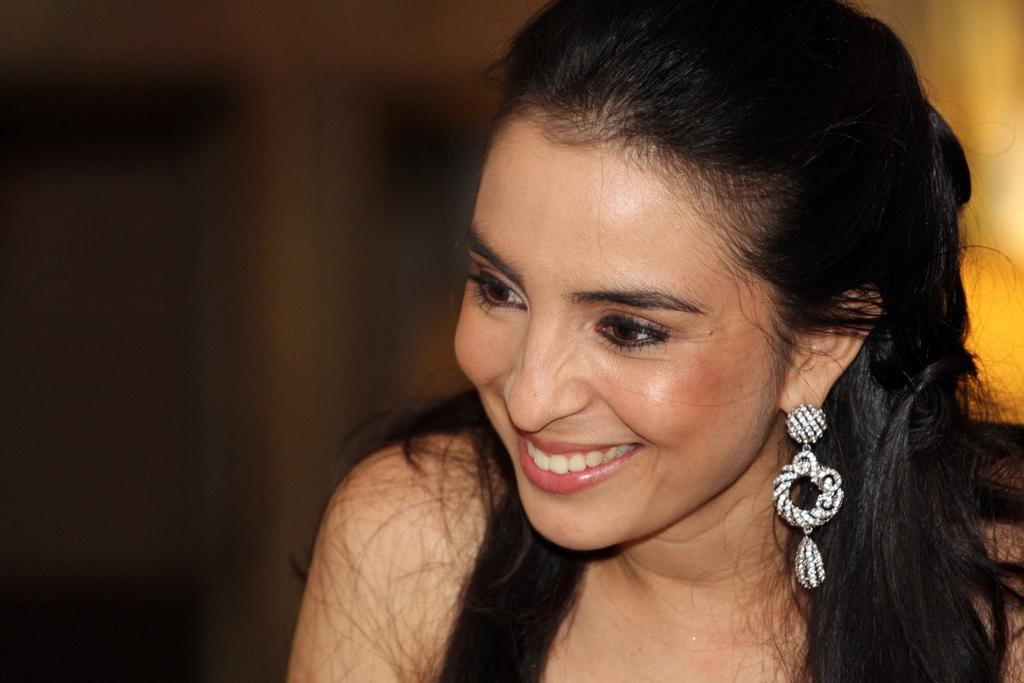What is located on the right side of the image? There is a woman on the right side of the image. What is the woman doing in the image? The woman is smiling in the image. Can you describe the background of the image? The background of the image is blurry. What type of mark can be seen on the woman's face in the image? There is no mark visible on the woman's face in the image. What level of education does the woman have, as indicated by the image? The image does not provide any information about the woman's education level. 